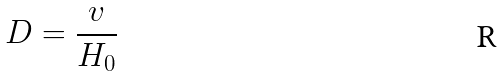<formula> <loc_0><loc_0><loc_500><loc_500>D = \frac { v } { H _ { 0 } }</formula> 